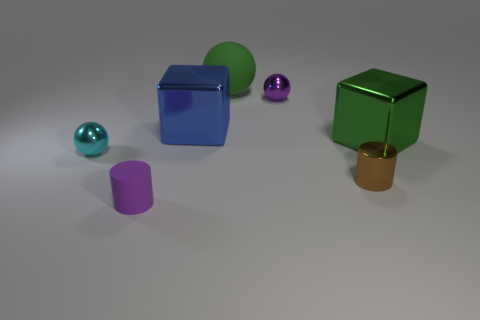There is a large blue object that is the same shape as the big green metal object; what is its material?
Provide a short and direct response. Metal. The metallic cylinder has what color?
Make the answer very short. Brown. Do the small rubber object and the small metal cylinder have the same color?
Offer a terse response. No. How many metallic objects are tiny objects or small cyan things?
Keep it short and to the point. 3. There is a big metallic object that is to the left of the tiny metallic sphere that is behind the large green cube; is there a large blue object in front of it?
Offer a very short reply. No. What is the size of the cyan thing that is made of the same material as the large blue cube?
Provide a succinct answer. Small. There is a tiny cyan metallic thing; are there any tiny brown metallic things right of it?
Offer a terse response. Yes. There is a ball left of the purple matte cylinder; are there any small purple rubber cylinders on the left side of it?
Provide a succinct answer. No. There is a metallic ball in front of the blue shiny block; is its size the same as the purple thing that is on the right side of the purple rubber thing?
Your answer should be very brief. Yes. What number of big objects are green rubber balls or purple metallic objects?
Your answer should be very brief. 1. 